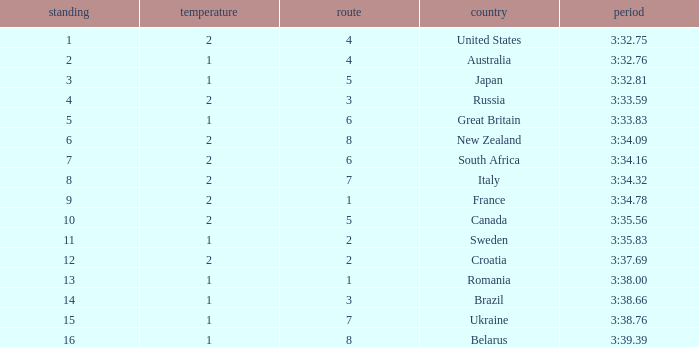Can you tell me the Rank that has the Lane of 6, and the Heat of 2? 7.0. 